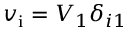<formula> <loc_0><loc_0><loc_500><loc_500>v _ { i } = V _ { 1 } \delta _ { i 1 }</formula> 